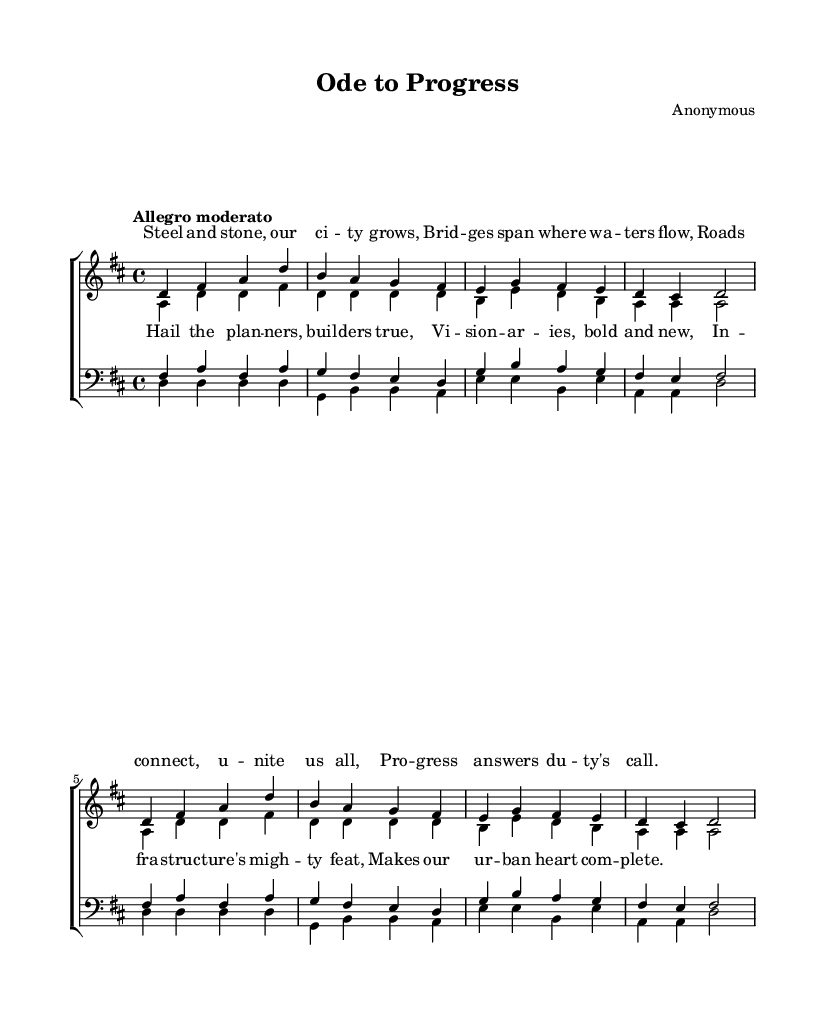What is the key signature of this music? The key signature is represented at the beginning of the sheet music, indicating the tonic and defining the suite of notes used in the piece. In this case, there are two sharps (F# and C#), indicating it's D major.
Answer: D major What is the time signature of this music? The time signature is indicated at the start of the music and shows how many beats are in each measure. Here, the time signature is 4/4, meaning there are four beats in a measure and the quarter note gets one beat.
Answer: 4/4 What is the tempo marking of this piece? The tempo marking appears at the beginning and dictates the speed of the piece. "Allegro moderato" suggests a moderately fast tempo, typically between 98 and 109 beats per minute.
Answer: Allegro moderato How many voices are present in the choir? By examining the score, we see that there are two groups: "women" (sopranos and altos) and "men" (tenors and basses), which totals four distinct voices.
Answer: Four Which voice sings the highest melody? The highest melody is found by comparing the ranges of the voice parts noted on the staff. The soprano voice is indicated as the highest pitch, generally singing above the other vocal parts.
Answer: Soprano What is the primary theme of the lyrics? The content of the lyrics provides context about infrastructure and urban growth, focusing on the positive impact of development. The theme celebrates progress and community.
Answer: Progress Count the number of measures in the soprano voice. By analyzing the musical phrases and counting each group of notes within the voice part of the soprano section, we find there are eight measures in total.
Answer: Eight 